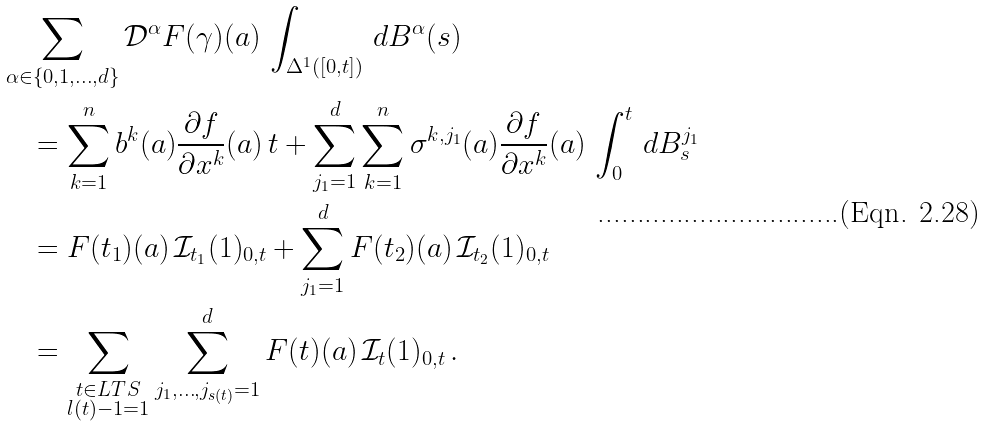<formula> <loc_0><loc_0><loc_500><loc_500>& \sum _ { \alpha \in \{ 0 , 1 , \dots , d \} } \mathcal { D } ^ { \alpha } F ( \gamma ) ( a ) \, \int _ { \Delta ^ { 1 } ( [ 0 , t ] ) } \, d B ^ { \alpha } ( s ) \\ & \quad = \sum _ { k = 1 } ^ { n } b ^ { k } ( a ) \frac { \partial f } { \partial x ^ { k } } ( a ) \, t + \sum _ { j _ { 1 } = 1 } ^ { d } \sum _ { k = 1 } ^ { n } \sigma ^ { k , j _ { 1 } } ( a ) \frac { \partial f } { \partial x ^ { k } } ( a ) \, \int _ { 0 } ^ { t } \, d B _ { s } ^ { j _ { 1 } } \\ & \quad = F ( t _ { 1 } ) ( a ) \, \mathcal { I } _ { t _ { 1 } } ( 1 ) _ { 0 , t } + \sum _ { j _ { 1 } = 1 } ^ { d } F ( t _ { 2 } ) ( a ) \, \mathcal { I } _ { t _ { 2 } } ( 1 ) _ { 0 , t } \\ & \quad = \sum _ { \substack { t \in L T S \\ l ( t ) - 1 = 1 } } \sum _ { j _ { 1 } , \dots , j _ { s ( t ) } = 1 } ^ { d } F ( t ) ( a ) \, \mathcal { I } _ { t } ( 1 ) _ { 0 , t } \, .</formula> 